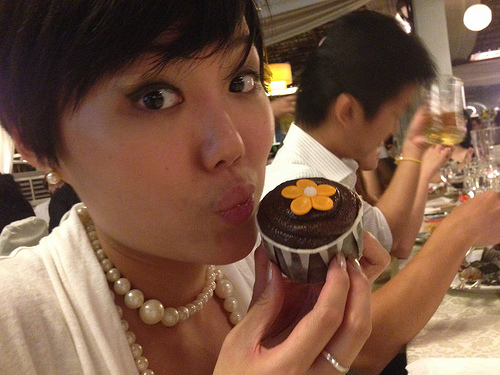Does the dark hair look long? No, the dark hair does not look long. It appears to be cropped short. 